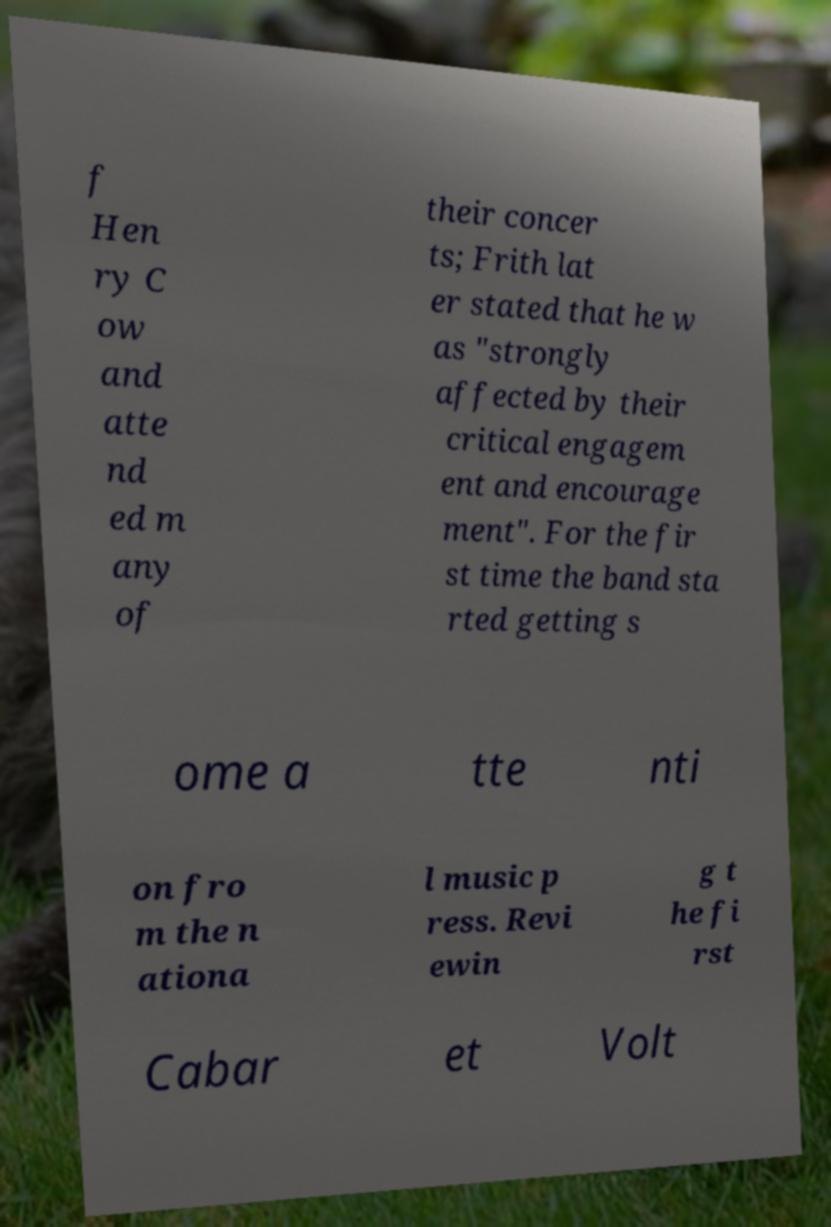Could you assist in decoding the text presented in this image and type it out clearly? f Hen ry C ow and atte nd ed m any of their concer ts; Frith lat er stated that he w as "strongly affected by their critical engagem ent and encourage ment". For the fir st time the band sta rted getting s ome a tte nti on fro m the n ationa l music p ress. Revi ewin g t he fi rst Cabar et Volt 